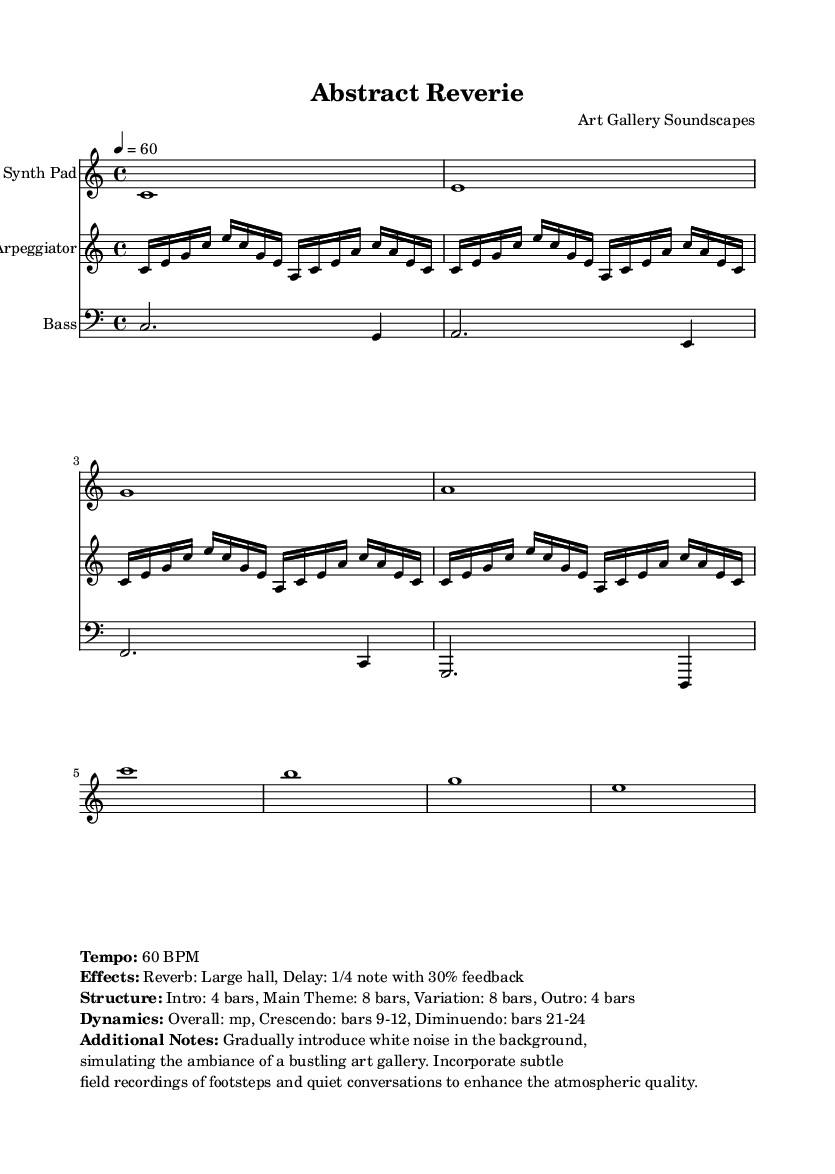What is the key signature of this music? The key signature is located at the beginning of the piece. It shows no sharps or flats, indicating that the tonality is based around the C major scale.
Answer: C major What is the time signature of this music? The time signature is shown in the first measure of the piece. It indicates that there are four beats per measure, represented by 4/4.
Answer: 4/4 What is the tempo of this piece? The tempo marking is specified in the markup section at the bottom of the sheet music. It states that the piece is to be played at a speed of 60 beats per minute.
Answer: 60 BPM How many measures are in the main theme section? The structure notation indicates that the main theme consists of 8 bars. This is directly stated in the markup.
Answer: 8 bars What type of sound effects are used in this composition? The sound effects are specified in the markup under the "Effects" heading, which lists "Reverb: Large hall" and "Delay: 1/4 note with 30% feedback."
Answer: Reverb and Delay What dynamic changes occur during the piece? The dynamics are indicated in the markup. It specifies that the overall dynamics are mezzo-piano (mp), with a crescendo from bars 9 to 12 and a diminuendo from bars 21 to 24.
Answer: Crescendo and Diminuendo What additional ambient elements are suggested to be incorporated? The additional notes in the markup indicate that white noise and field recordings of footsteps and quiet conversations should be included to enhance the atmosphere, simulating an art gallery environment.
Answer: White noise and field recordings 